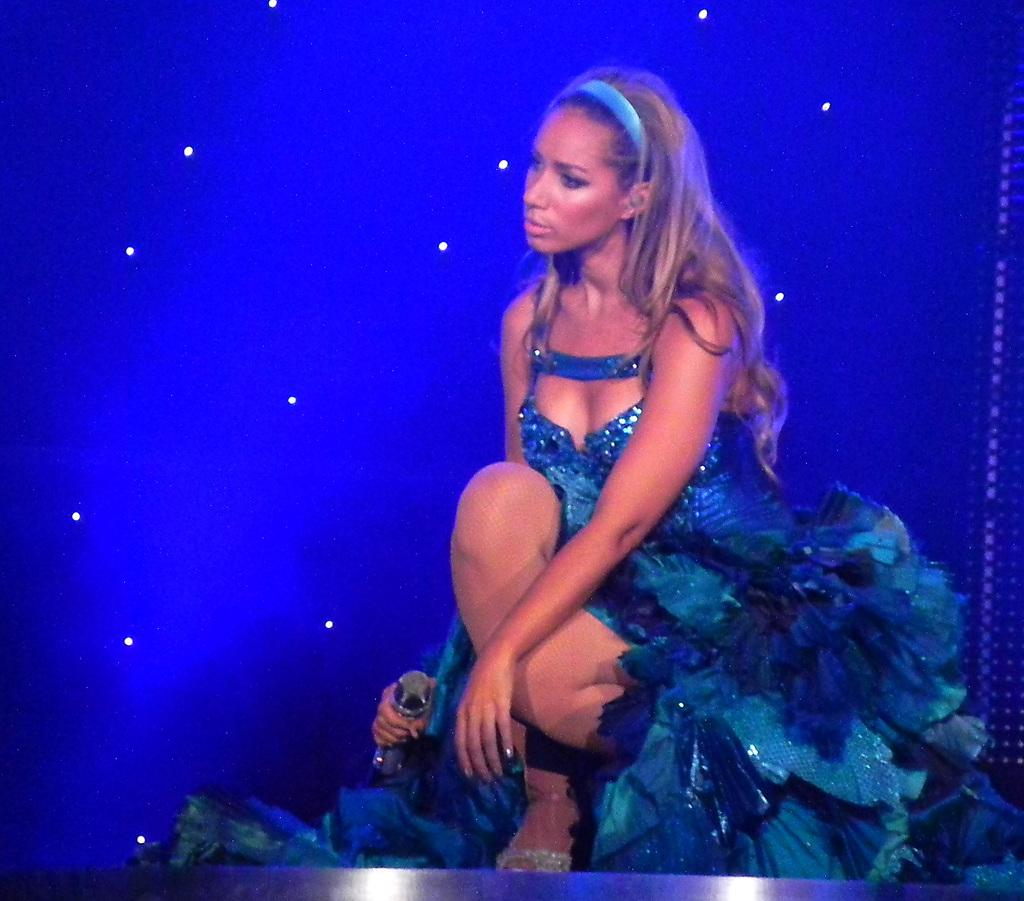Who is the main subject in the image? There is a woman in the image. What is the woman wearing? The woman is wearing a blue dress. What is the woman holding in the image? The woman is holding a microphone. What is the color of the background in the image? The background in the image is blue. Can you describe any patterns or details on the background? There are white dots on the blue background. What type of treatment is the woman receiving for her feelings in the image? There is no indication in the image that the woman is receiving any treatment for her feelings. 